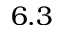<formula> <loc_0><loc_0><loc_500><loc_500>6 . 3</formula> 